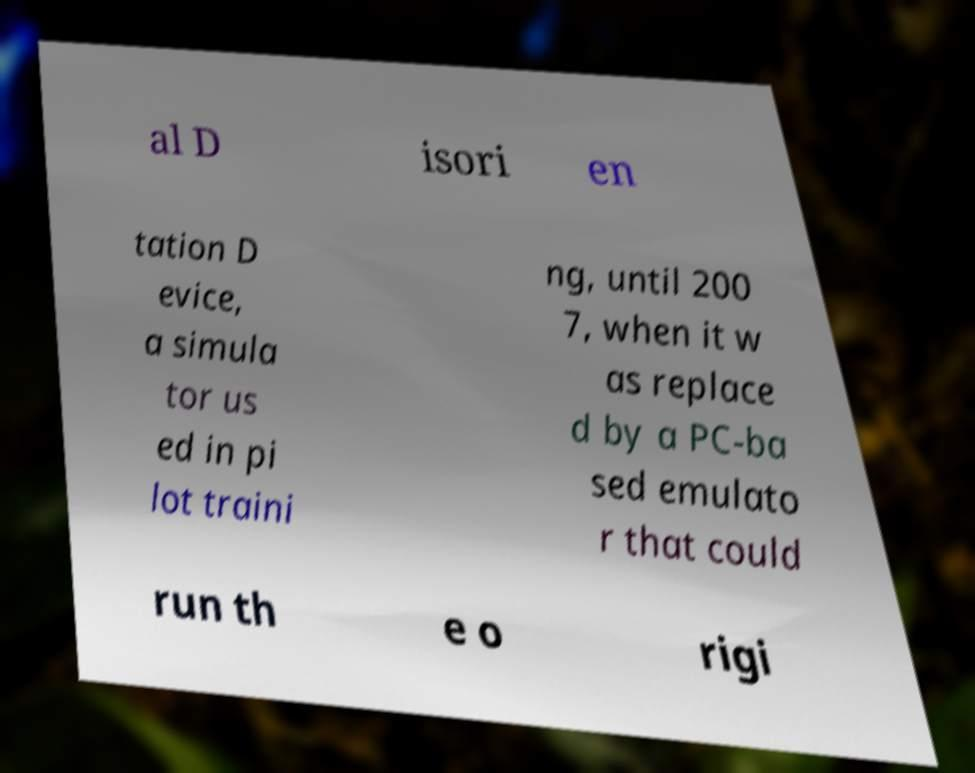Can you read and provide the text displayed in the image?This photo seems to have some interesting text. Can you extract and type it out for me? al D isori en tation D evice, a simula tor us ed in pi lot traini ng, until 200 7, when it w as replace d by a PC-ba sed emulato r that could run th e o rigi 